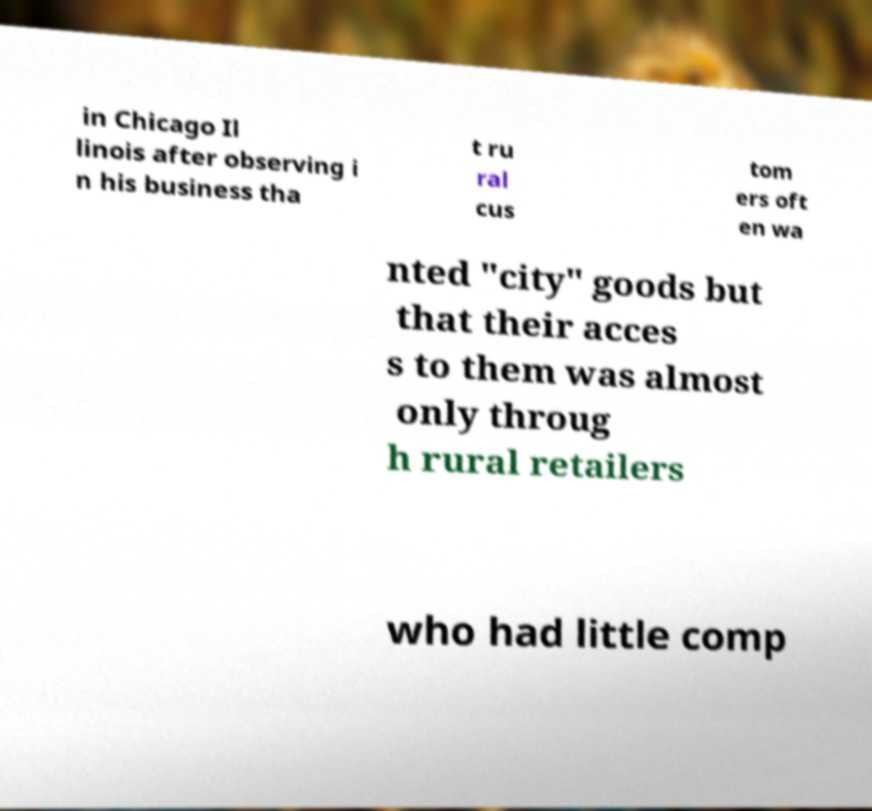There's text embedded in this image that I need extracted. Can you transcribe it verbatim? in Chicago Il linois after observing i n his business tha t ru ral cus tom ers oft en wa nted "city" goods but that their acces s to them was almost only throug h rural retailers who had little comp 